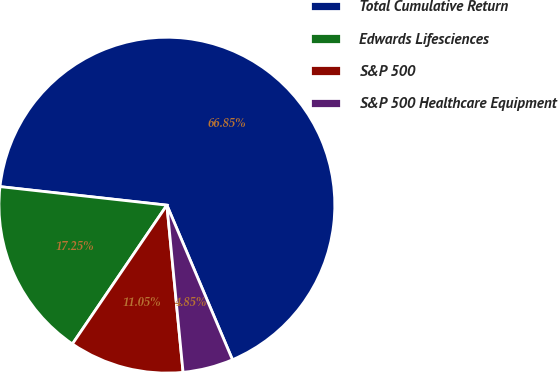Convert chart. <chart><loc_0><loc_0><loc_500><loc_500><pie_chart><fcel>Total Cumulative Return<fcel>Edwards Lifesciences<fcel>S&P 500<fcel>S&P 500 Healthcare Equipment<nl><fcel>66.86%<fcel>17.25%<fcel>11.05%<fcel>4.85%<nl></chart> 